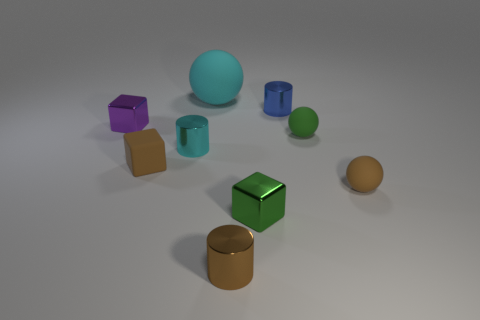Subtract all tiny balls. How many balls are left? 1 Subtract 1 balls. How many balls are left? 2 Add 1 small green things. How many objects exist? 10 Subtract all cubes. How many objects are left? 6 Add 8 big objects. How many big objects are left? 9 Add 9 big brown objects. How many big brown objects exist? 9 Subtract 0 red balls. How many objects are left? 9 Subtract all small red shiny cylinders. Subtract all small rubber things. How many objects are left? 6 